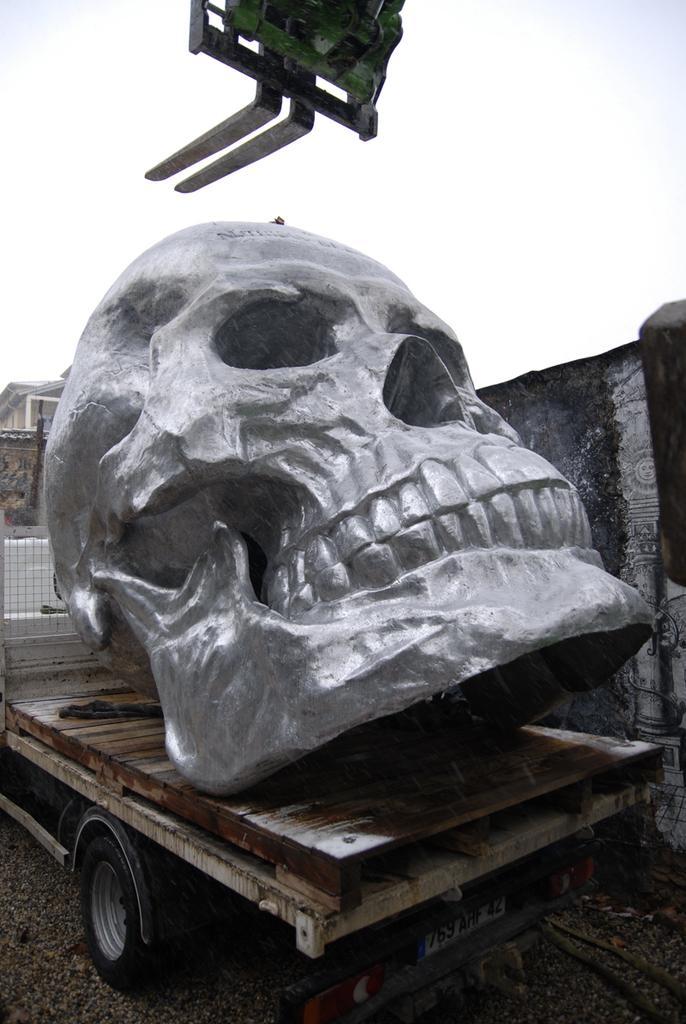Could you give a brief overview of what you see in this image? In the image there is a sculpture of a skull kept on a truck and behind that there is a wall. 